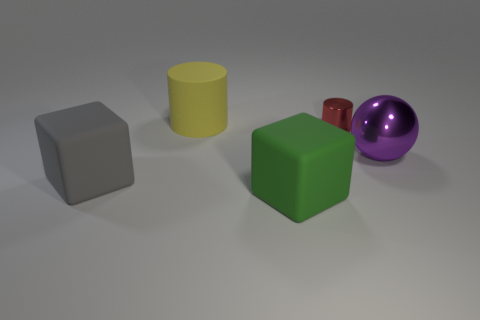The tiny metal cylinder has what color?
Offer a very short reply. Red. The cylinder that is the same size as the shiny sphere is what color?
Ensure brevity in your answer.  Yellow. What number of metallic objects are tiny red objects or small green objects?
Give a very brief answer. 1. What number of large things are both in front of the big rubber cylinder and left of the large purple metallic ball?
Offer a very short reply. 2. Is there anything else that is the same shape as the green matte thing?
Keep it short and to the point. Yes. What number of other objects are there of the same size as the matte cylinder?
Your answer should be very brief. 3. Is the size of the block on the right side of the large yellow cylinder the same as the rubber thing behind the large gray block?
Provide a short and direct response. Yes. How many things are tiny red things or large objects that are behind the gray matte cube?
Provide a succinct answer. 3. How big is the cube that is in front of the gray cube?
Make the answer very short. Large. Are there fewer metal balls behind the red object than large green matte blocks that are left of the large yellow cylinder?
Keep it short and to the point. No. 